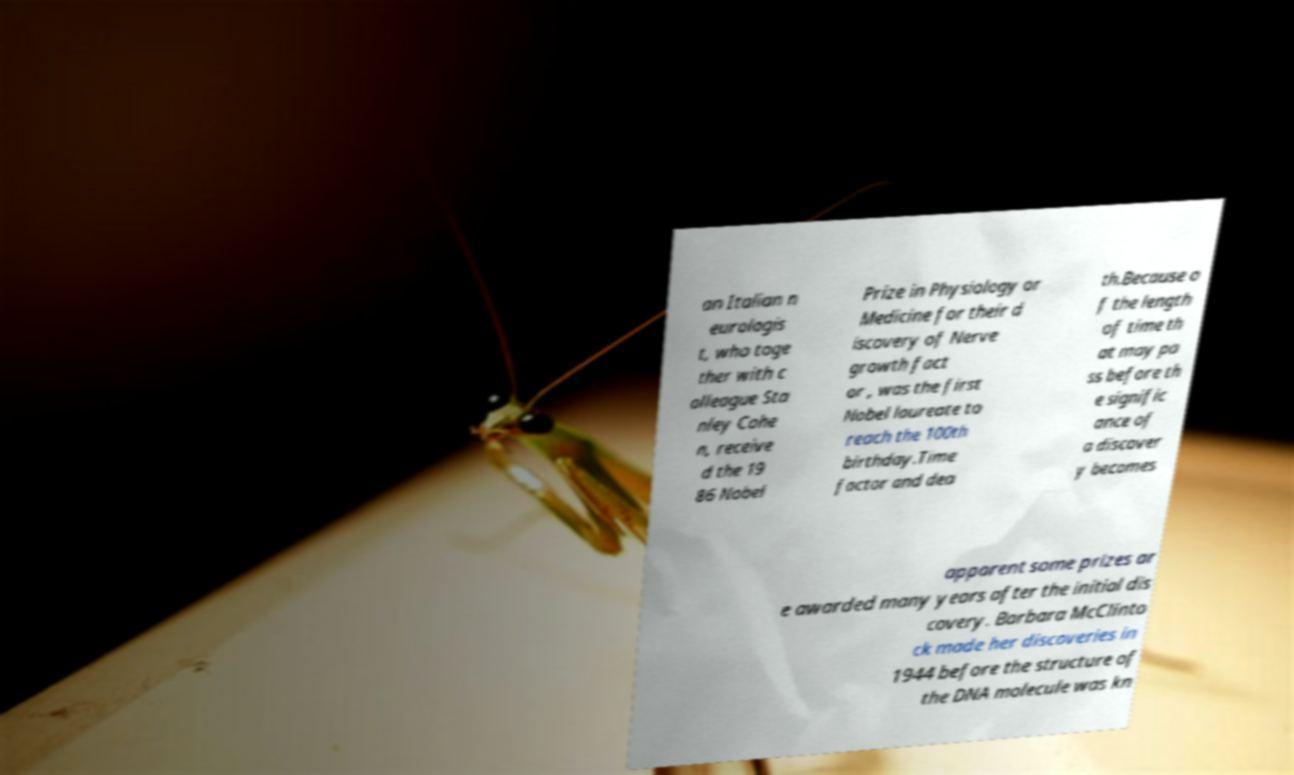Can you accurately transcribe the text from the provided image for me? an Italian n eurologis t, who toge ther with c olleague Sta nley Cohe n, receive d the 19 86 Nobel Prize in Physiology or Medicine for their d iscovery of Nerve growth fact or , was the first Nobel laureate to reach the 100th birthday.Time factor and dea th.Because o f the length of time th at may pa ss before th e signific ance of a discover y becomes apparent some prizes ar e awarded many years after the initial dis covery. Barbara McClinto ck made her discoveries in 1944 before the structure of the DNA molecule was kn 